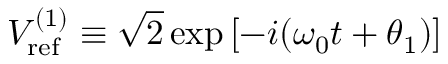Convert formula to latex. <formula><loc_0><loc_0><loc_500><loc_500>V _ { r e f } ^ { ( 1 ) } \equiv \sqrt { 2 } \exp \left [ - i ( \omega _ { 0 } t + \theta _ { 1 } ) \right ]</formula> 